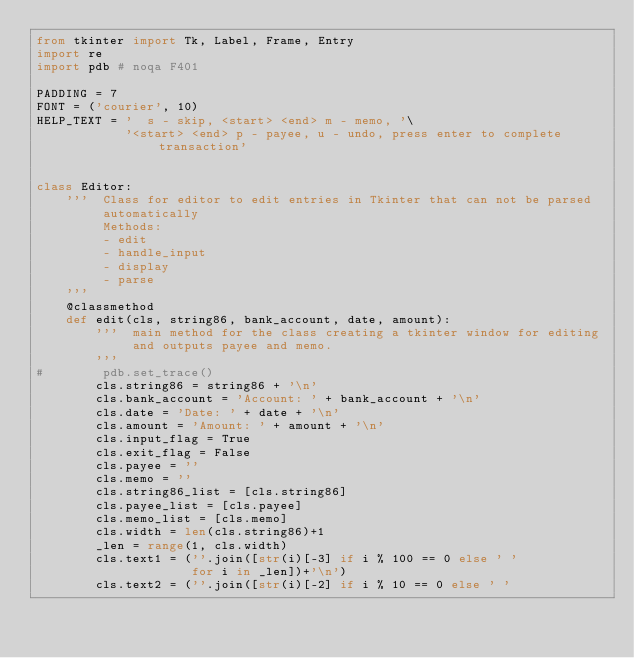<code> <loc_0><loc_0><loc_500><loc_500><_Python_>from tkinter import Tk, Label, Frame, Entry
import re
import pdb # noqa F401

PADDING = 7
FONT = ('courier', 10)
HELP_TEXT = '  s - skip, <start> <end> m - memo, '\
            '<start> <end> p - payee, u - undo, press enter to complete transaction'


class Editor:
    '''  Class for editor to edit entries in Tkinter that can not be parsed
         automatically
         Methods:
         - edit
         - handle_input
         - display
         - parse
    '''
    @classmethod
    def edit(cls, string86, bank_account, date, amount):
        '''  main method for the class creating a tkinter window for editing
             and outputs payee and memo.
        '''
#        pdb.set_trace()
        cls.string86 = string86 + '\n'
        cls.bank_account = 'Account: ' + bank_account + '\n'
        cls.date = 'Date: ' + date + '\n'
        cls.amount = 'Amount: ' + amount + '\n'
        cls.input_flag = True
        cls.exit_flag = False
        cls.payee = ''
        cls.memo = ''
        cls.string86_list = [cls.string86]
        cls.payee_list = [cls.payee]
        cls.memo_list = [cls.memo]
        cls.width = len(cls.string86)+1
        _len = range(1, cls.width)
        cls.text1 = (''.join([str(i)[-3] if i % 100 == 0 else ' '
                     for i in _len])+'\n')
        cls.text2 = (''.join([str(i)[-2] if i % 10 == 0 else ' '</code> 